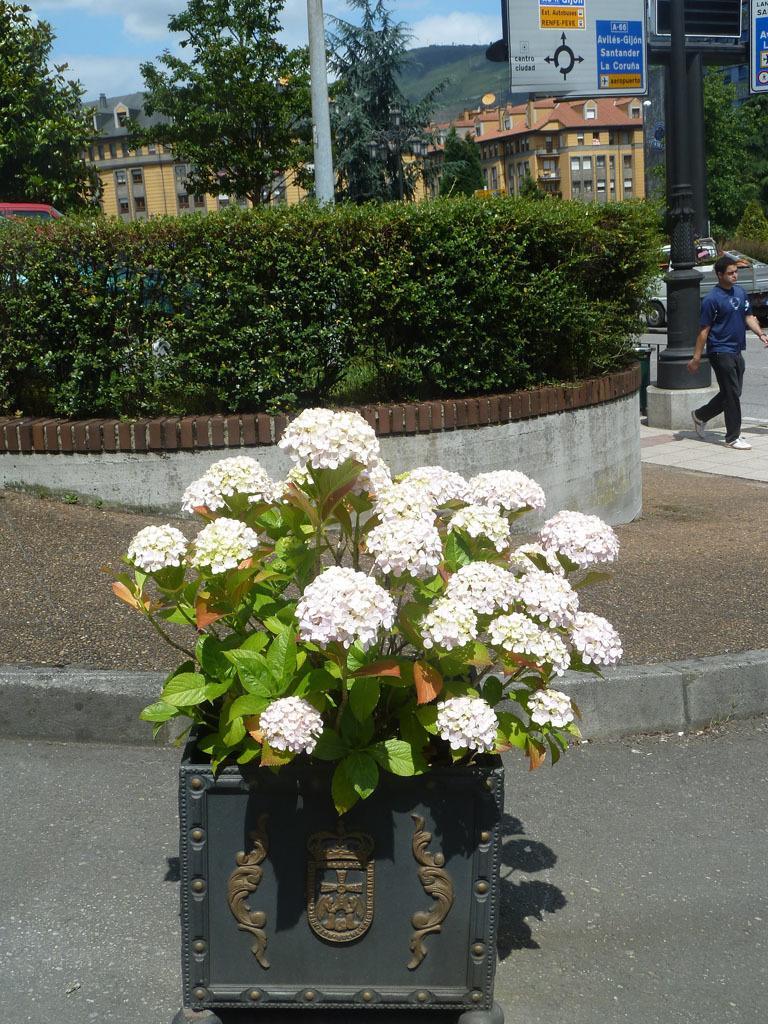How would you summarize this image in a sentence or two? In this image I can see number of white colour flowers and green leaves in the front. In the background I can see bushes, few poles, few boards, few buildings, clouds, the sky and on these boards I can see something is written. On the right side of this image I can see a man and I can also see few vehicles on the both sides of the image. 